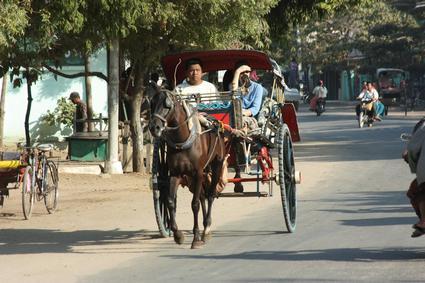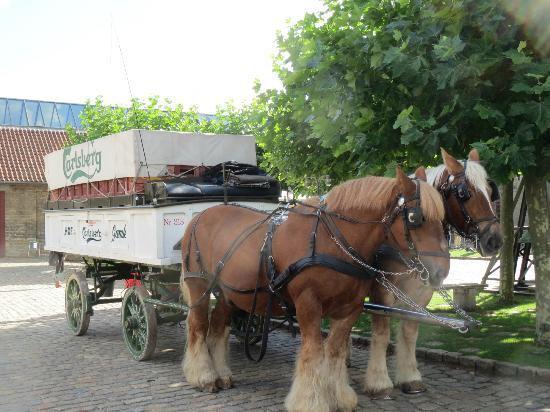The first image is the image on the left, the second image is the image on the right. Evaluate the accuracy of this statement regarding the images: "Right image shows a four-wheeled cart puled by one horse.". Is it true? Answer yes or no. No. The first image is the image on the left, the second image is the image on the right. Examine the images to the left and right. Is the description "a brown horse pulls a small carriage with 2 people on it" accurate? Answer yes or no. Yes. 